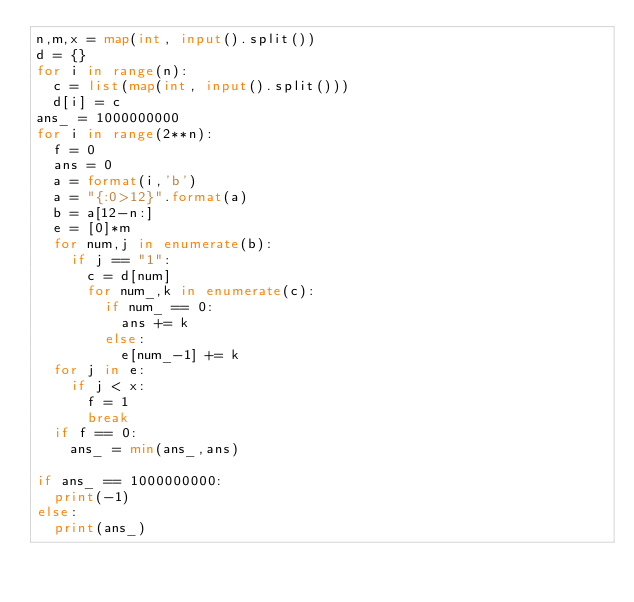Convert code to text. <code><loc_0><loc_0><loc_500><loc_500><_Python_>n,m,x = map(int, input().split())
d = {}
for i in range(n):
  c = list(map(int, input().split()))
  d[i] = c
ans_ = 1000000000
for i in range(2**n):
  f = 0
  ans = 0
  a = format(i,'b')
  a = "{:0>12}".format(a)
  b = a[12-n:]
  e = [0]*m
  for num,j in enumerate(b):
    if j == "1":
      c = d[num]
      for num_,k in enumerate(c):
        if num_ == 0:
          ans += k
        else:
          e[num_-1] += k
  for j in e:
    if j < x:
      f = 1
      break
  if f == 0:
    ans_ = min(ans_,ans)

if ans_ == 1000000000:
  print(-1)
else:
  print(ans_)</code> 